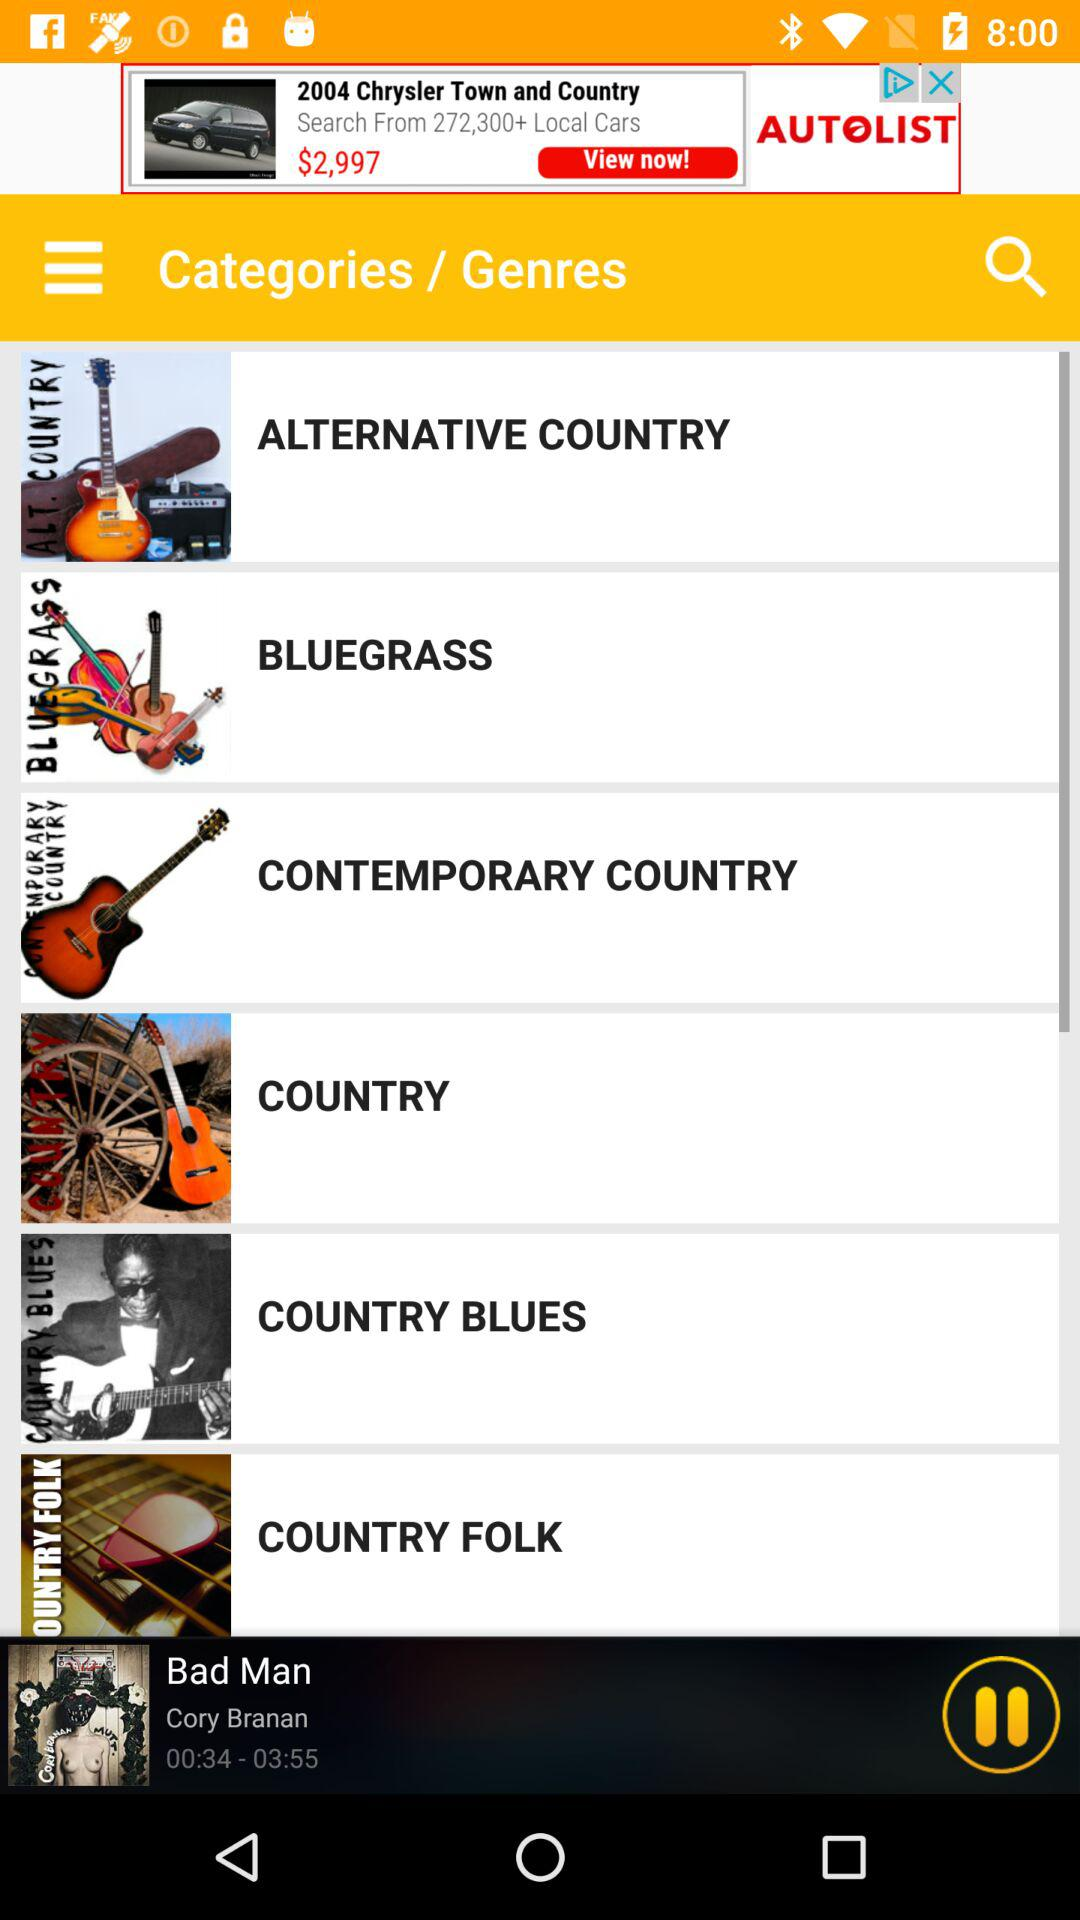Who is the singer? The singer is Cory Branan. 